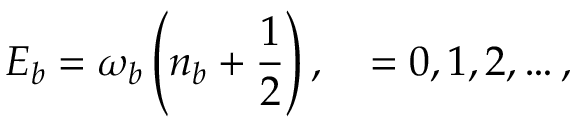<formula> <loc_0><loc_0><loc_500><loc_500>E _ { b } = \omega _ { b } \left ( n _ { b } + \frac { 1 } { 2 } \right ) , \quad = 0 , 1 , 2 , \dots ,</formula> 